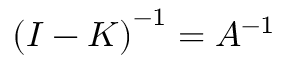Convert formula to latex. <formula><loc_0><loc_0><loc_500><loc_500>\left ( I - K \right ) ^ { - 1 } = A ^ { - 1 }</formula> 